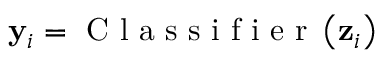Convert formula to latex. <formula><loc_0><loc_0><loc_500><loc_500>{ y } _ { i } = C l a s s i f i e r \left ( z _ { i } \right )</formula> 